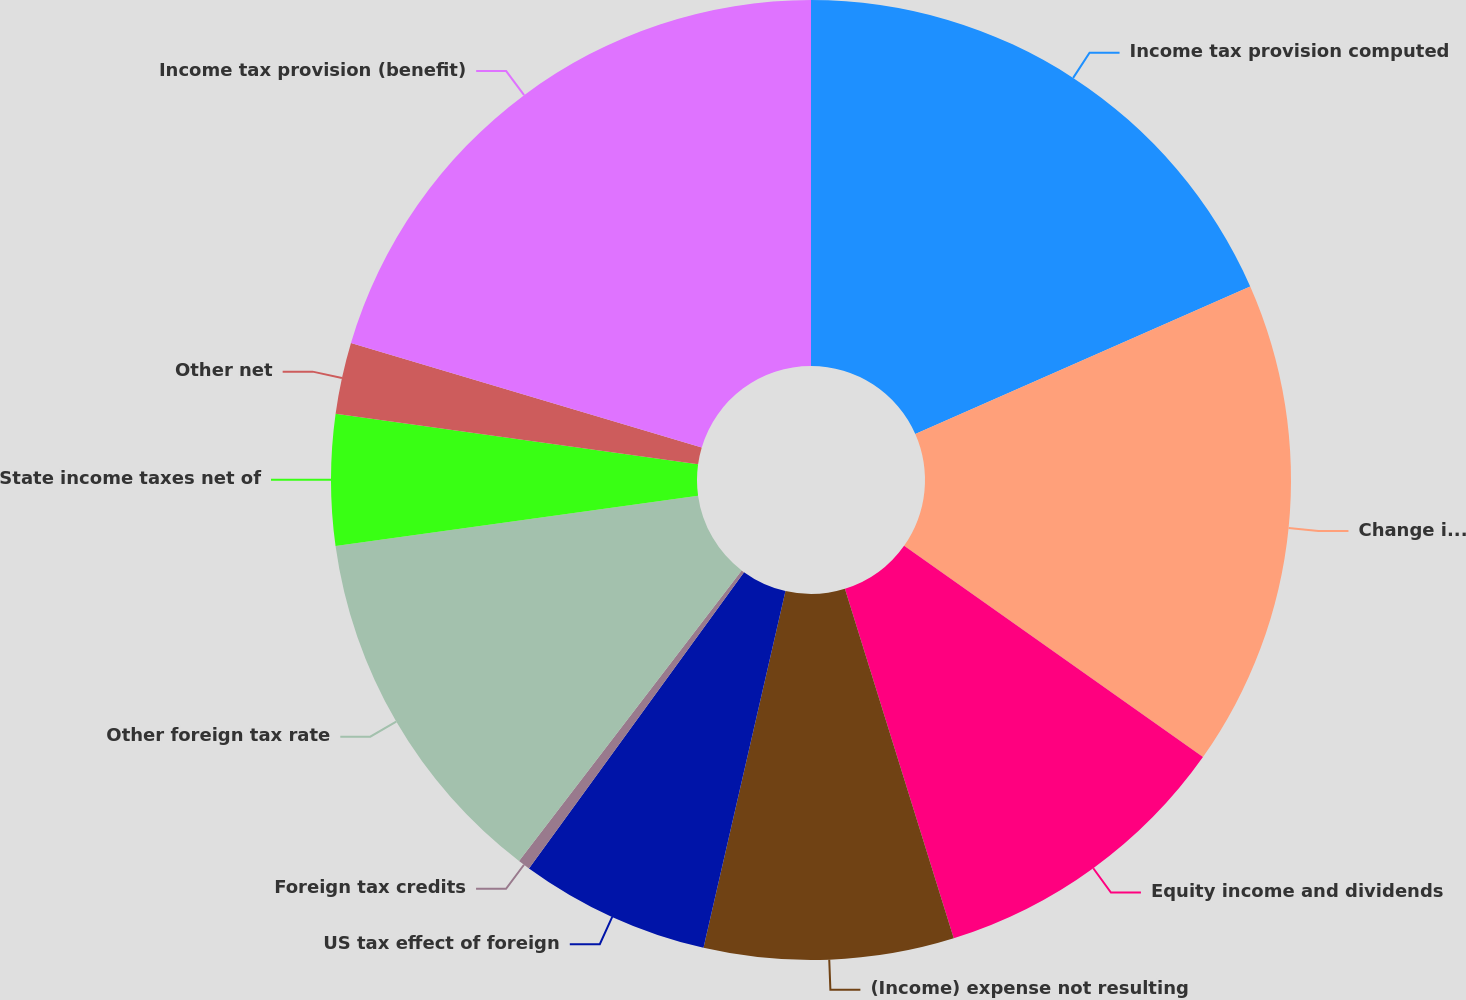Convert chart. <chart><loc_0><loc_0><loc_500><loc_500><pie_chart><fcel>Income tax provision computed<fcel>Change in valuation allowance<fcel>Equity income and dividends<fcel>(Income) expense not resulting<fcel>US tax effect of foreign<fcel>Foreign tax credits<fcel>Other foreign tax rate<fcel>State income taxes net of<fcel>Other net<fcel>Income tax provision (benefit)<nl><fcel>18.39%<fcel>16.4%<fcel>10.4%<fcel>8.4%<fcel>6.4%<fcel>0.41%<fcel>12.4%<fcel>4.4%<fcel>2.4%<fcel>20.39%<nl></chart> 